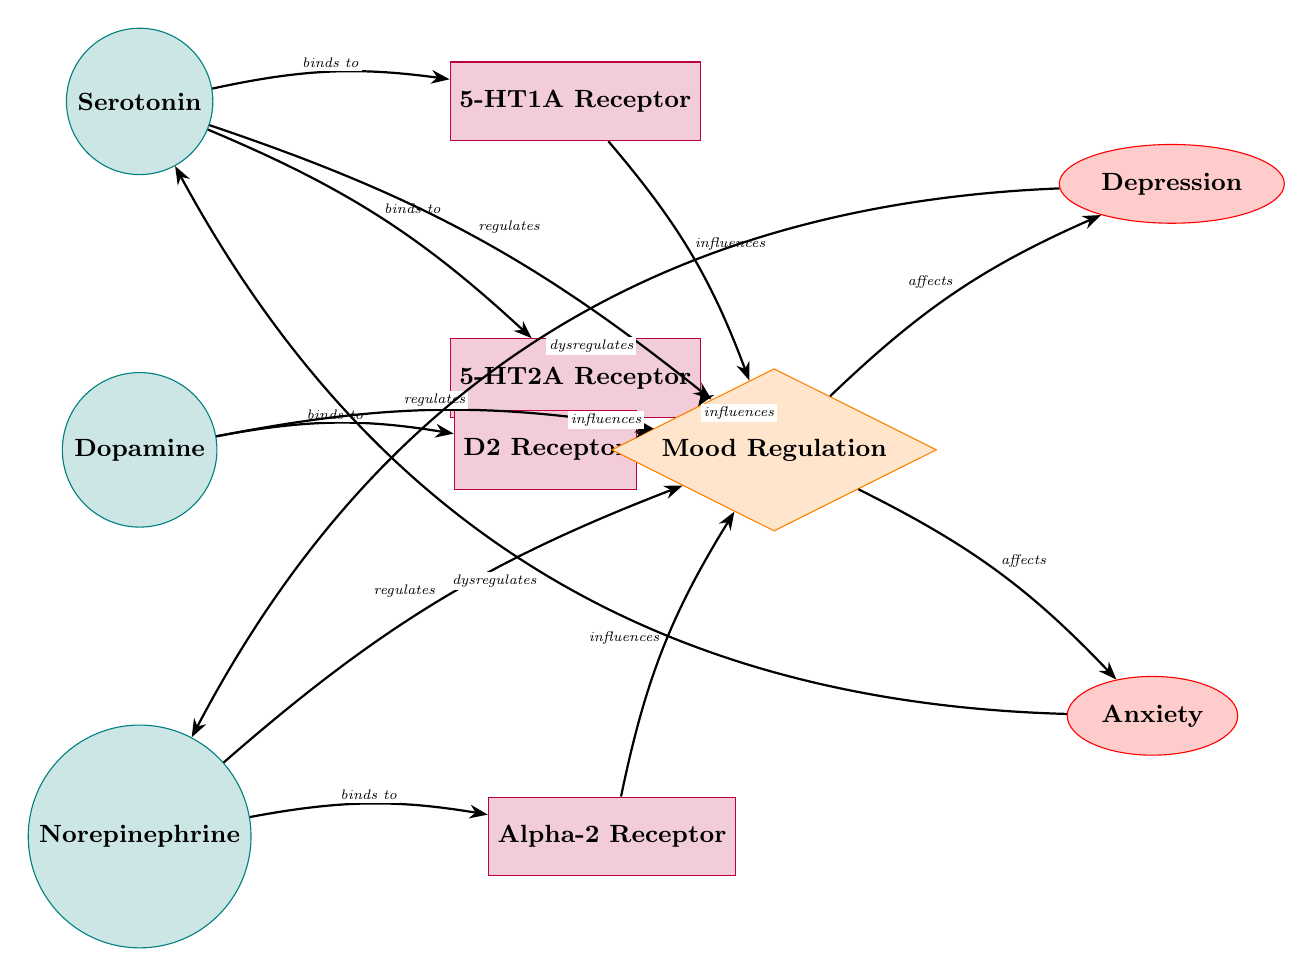What are the three neurotransmitters illustrated in the diagram? The diagram displays three neurotransmitters: serotonin, dopamine, and norepinephrine. They are each represented as individual nodes positioned vertically.
Answer: serotonin, dopamine, norepinephrine Which receptor does serotonin bind to? The diagram shows that serotonin binds to two receptors: 5-HT1A and 5-HT2A, as indicated by directed edges from the serotonin node to these receptor nodes.
Answer: 5-HT1A, 5-HT2A How many disorders are represented in the diagram? In the diagram, there are two disorders displayed: depression and anxiety. They are represented as elliptical nodes positioned to the right of the mood regulation process.
Answer: 2 What is the influence of the D2 receptor on mood? According to the diagram, the D2 receptor influences mood, which is displayed through a directed edge from the D2 node to the mood node.
Answer: influences What happens to norepinephrine in relation to depression? The diagram indicates that depression dysregulates norepinephrine, which is represented by a directed edge bending from the depression node back to the norepinephrine node.
Answer: dysregulates Which neurotransmitter is associated with anxiety regulation? The diagram specifies that serotonin is dysregulated in anxiety, shown through a directed edge bending from the anxiety node to the serotonin node, indicating a negative feedback relationship.
Answer: serotonin How does dopamine contribute to mood regulation? The diagram illustrates that dopamine regulates mood, shown by a directed edge from the dopamine node to the mood node, indicating a direct influence on mood.
Answer: regulates What type of diagram is this representing? The diagram is a biomedical diagram, showcasing interactions among neurotransmitters and their roles in mood disorders. This is indicated by its structured components including neurotransmitters and receptors linked to mood and disorders.
Answer: Biomedical Diagram What is the connection between mood and anxiety in this diagram? The diagram shows that mood affects anxiety, as indicated by a directed edge from the mood node to the anxiety disorder node, which suggests that changes in mood can influence anxiety levels.
Answer: affects 